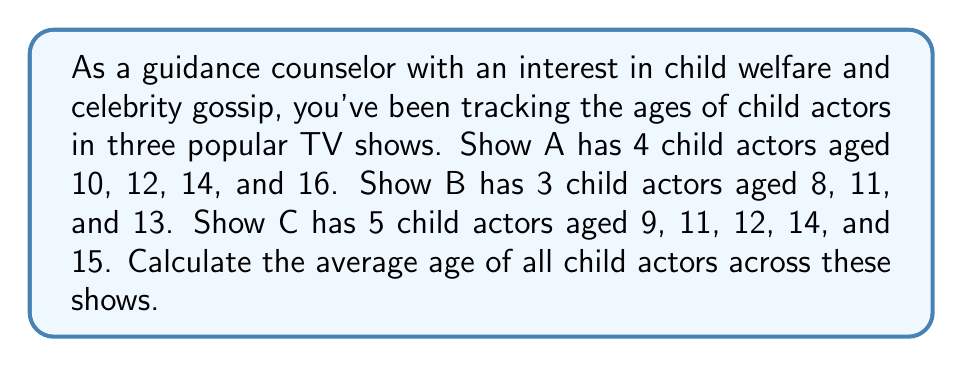Could you help me with this problem? Let's approach this step-by-step:

1) First, let's sum up the ages for each show:
   Show A: $10 + 12 + 14 + 16 = 52$
   Show B: $8 + 11 + 13 = 32$
   Show C: $9 + 11 + 12 + 14 + 15 = 61$

2) Now, let's add up all these sums:
   $52 + 32 + 61 = 145$

3) Next, we need to count the total number of child actors:
   Show A: 4 actors
   Show B: 3 actors
   Show C: 5 actors
   Total: $4 + 3 + 5 = 12$ actors

4) To calculate the average, we divide the sum of all ages by the total number of actors:

   $\text{Average} = \frac{\text{Sum of all ages}}{\text{Total number of actors}}$

   $\text{Average} = \frac{145}{12}$

5) Simplifying this fraction:
   $\frac{145}{12} = 12.0833...$

6) Rounding to two decimal places:
   $12.08$ years
Answer: $12.08$ years 